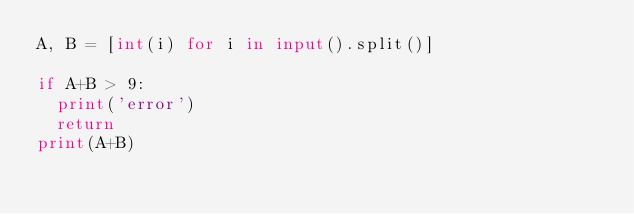Convert code to text. <code><loc_0><loc_0><loc_500><loc_500><_Python_>A, B = [int(i) for i in input().split()]

if A+B > 9:
	print('error')
	return
print(A+B)</code> 